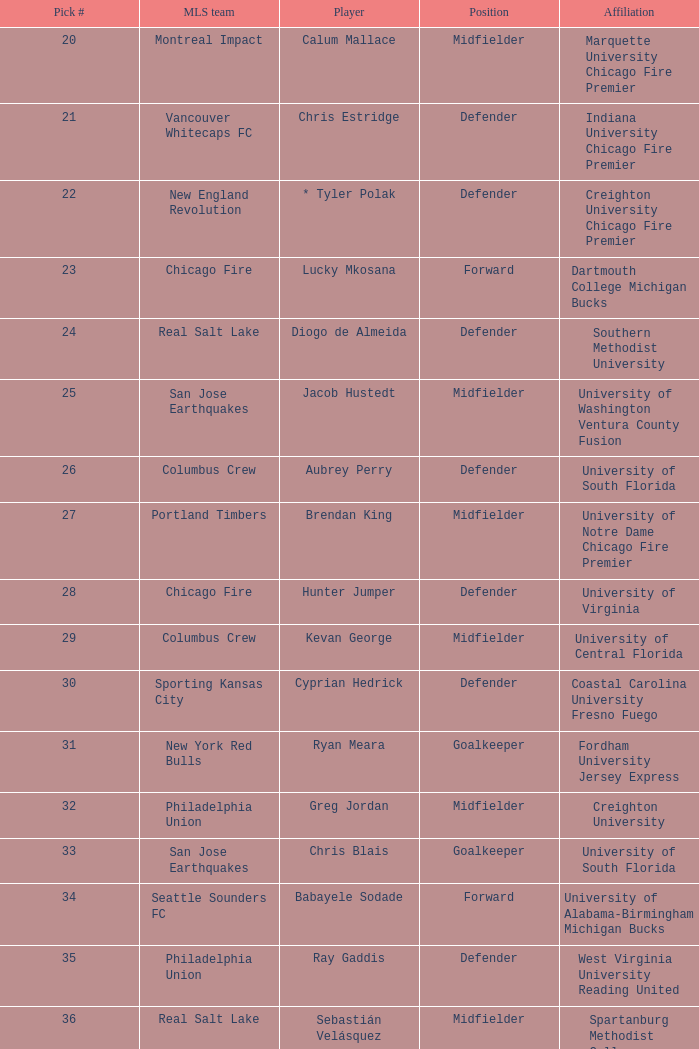What MLS team picked Babayele Sodade? Seattle Sounders FC. 